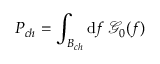Convert formula to latex. <formula><loc_0><loc_0><loc_500><loc_500>P _ { c h } = \int _ { B _ { c h } } d f \, \mathcal { G } _ { 0 } ( f )</formula> 